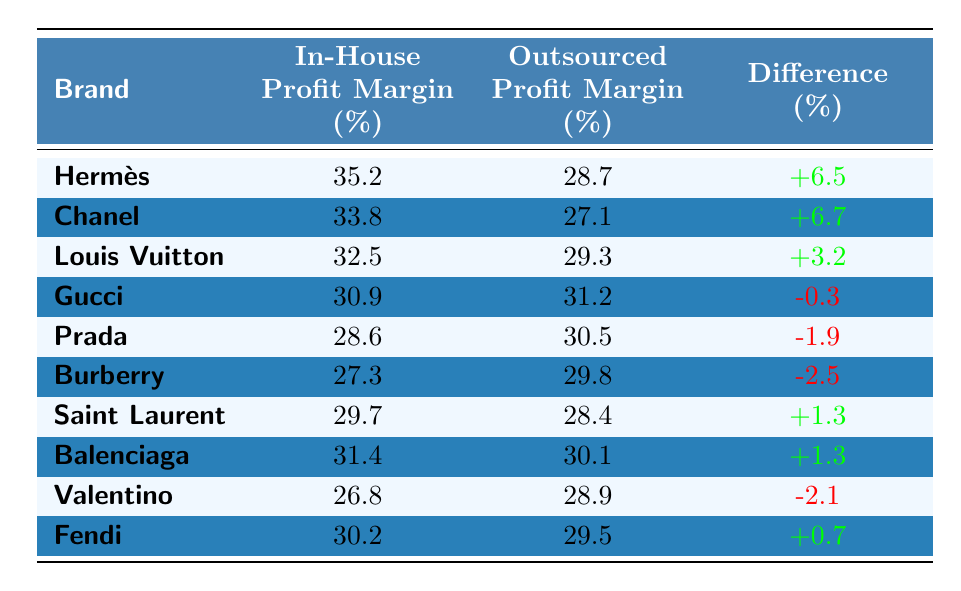What's the profit margin for Hermès in-house production? The table shows that Hermès has an in-house profit margin of 35.2%.
Answer: 35.2% Which brand has the highest in-house profit margin? By reviewing the in-house profit margins, Hermès at 35.2% has the highest profit margin compared to other brands listed.
Answer: Hermès What is the difference in profit margin for Chanel between in-house production and outsourcing? For Chanel, the in-house profit margin is 33.8% and the outsourced margin is 27.1%. The difference is calculated as 33.8% - 27.1% = 6.7%.
Answer: 6.7% Which brand shows a negative difference in profit margins? The brands with negative differences are Gucci (-0.3%), Prada (-1.9%), Burberry (-2.5%), and Valentino (-2.1%).
Answer: Gucci, Prada, Burberry, Valentino What is the average in-house profit margin for the brands listed? The in-house profit margins are 35.2, 33.8, 32.5, 30.9, 28.6, 27.3, 29.7, 31.4, 26.8, and 30.2, summing these gives  35.2 + 33.8 + 32.5 + 30.9 + 28.6 + 27.3 + 29.7 + 31.4 + 26.8 + 30.2 =  334.4. Dividing by 10 gives an average of 33.44%.
Answer: 33.4% Is the out-sourced profit margin for Gucci higher than its in-house margin? The outsourced profit margin for Gucci is 31.2%, which is higher than its in-house margin of 30.9%.
Answer: Yes What brand has the smallest difference in profit margins, and what is that difference? The smallest difference is for Gucci, which has a difference of -0.3%.
Answer: Gucci, -0.3% If a brand has an in-house profit margin of 30%, what would you expect their outsourced margin to be compared to the average listed? If the brand's in-house profit margin is 30%, then based on average outsourced profit margins (which are lower than their in-house), expected margins would likely be lower than 29.5% based on the table data.
Answer: Lower than 29.5% Which brand has a 0.7% positive difference in profit margins? The brand with a 0.7% positive difference is Fendi, as shown in the table.
Answer: Fendi What is the total profit margin difference for all brands combined? By adding all the differences: 6.5 + 6.7 + 3.2 - 0.3 - 1.9 - 2.5 + 1.3 + 1.3 - 2.1 + 0.7 = 13.8%.
Answer: 13.8% 